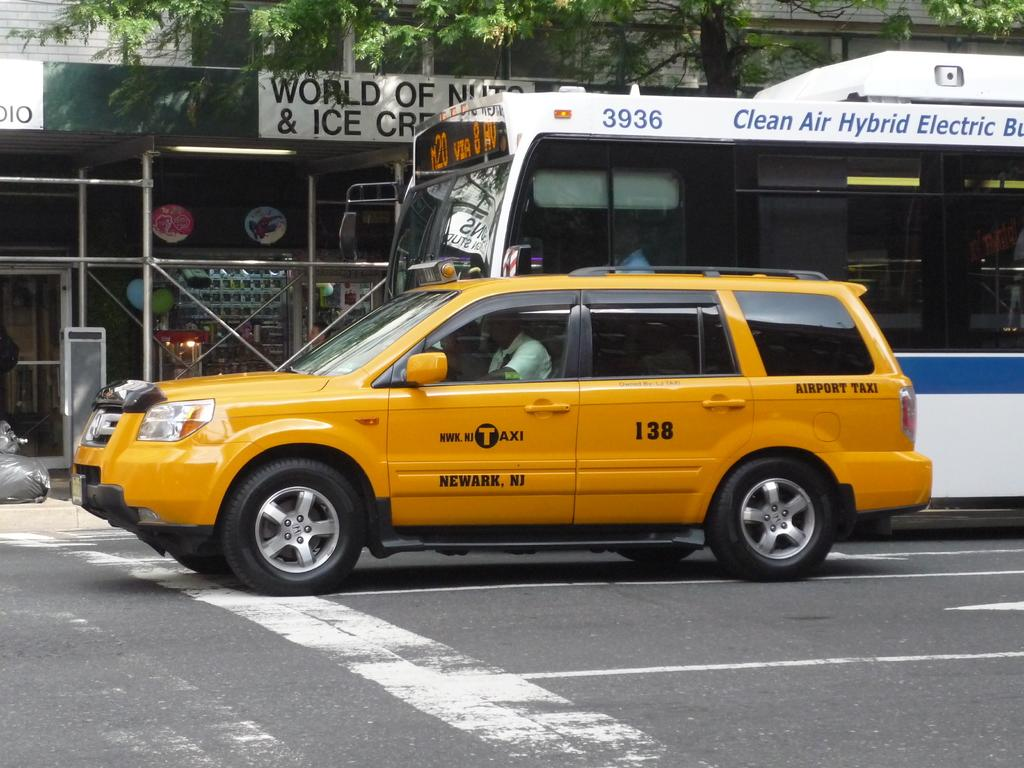Provide a one-sentence caption for the provided image. A taxi is sitting next to to a public bus on the street. 